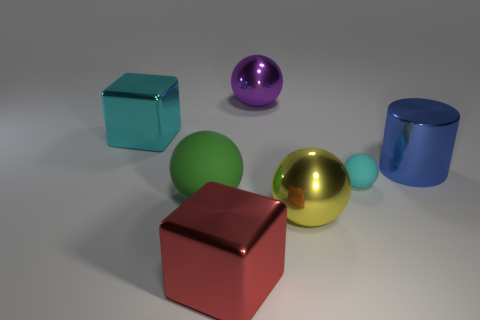What number of things are blue cylinders or metallic blocks to the right of the big cyan object? Upon examining the image, there is one blue cylinder and one metallic block that appear to the right of the large cyan cube. So, the total count of items that are either blue cylinders or metallic blocks to the right of the cyan object is two. 